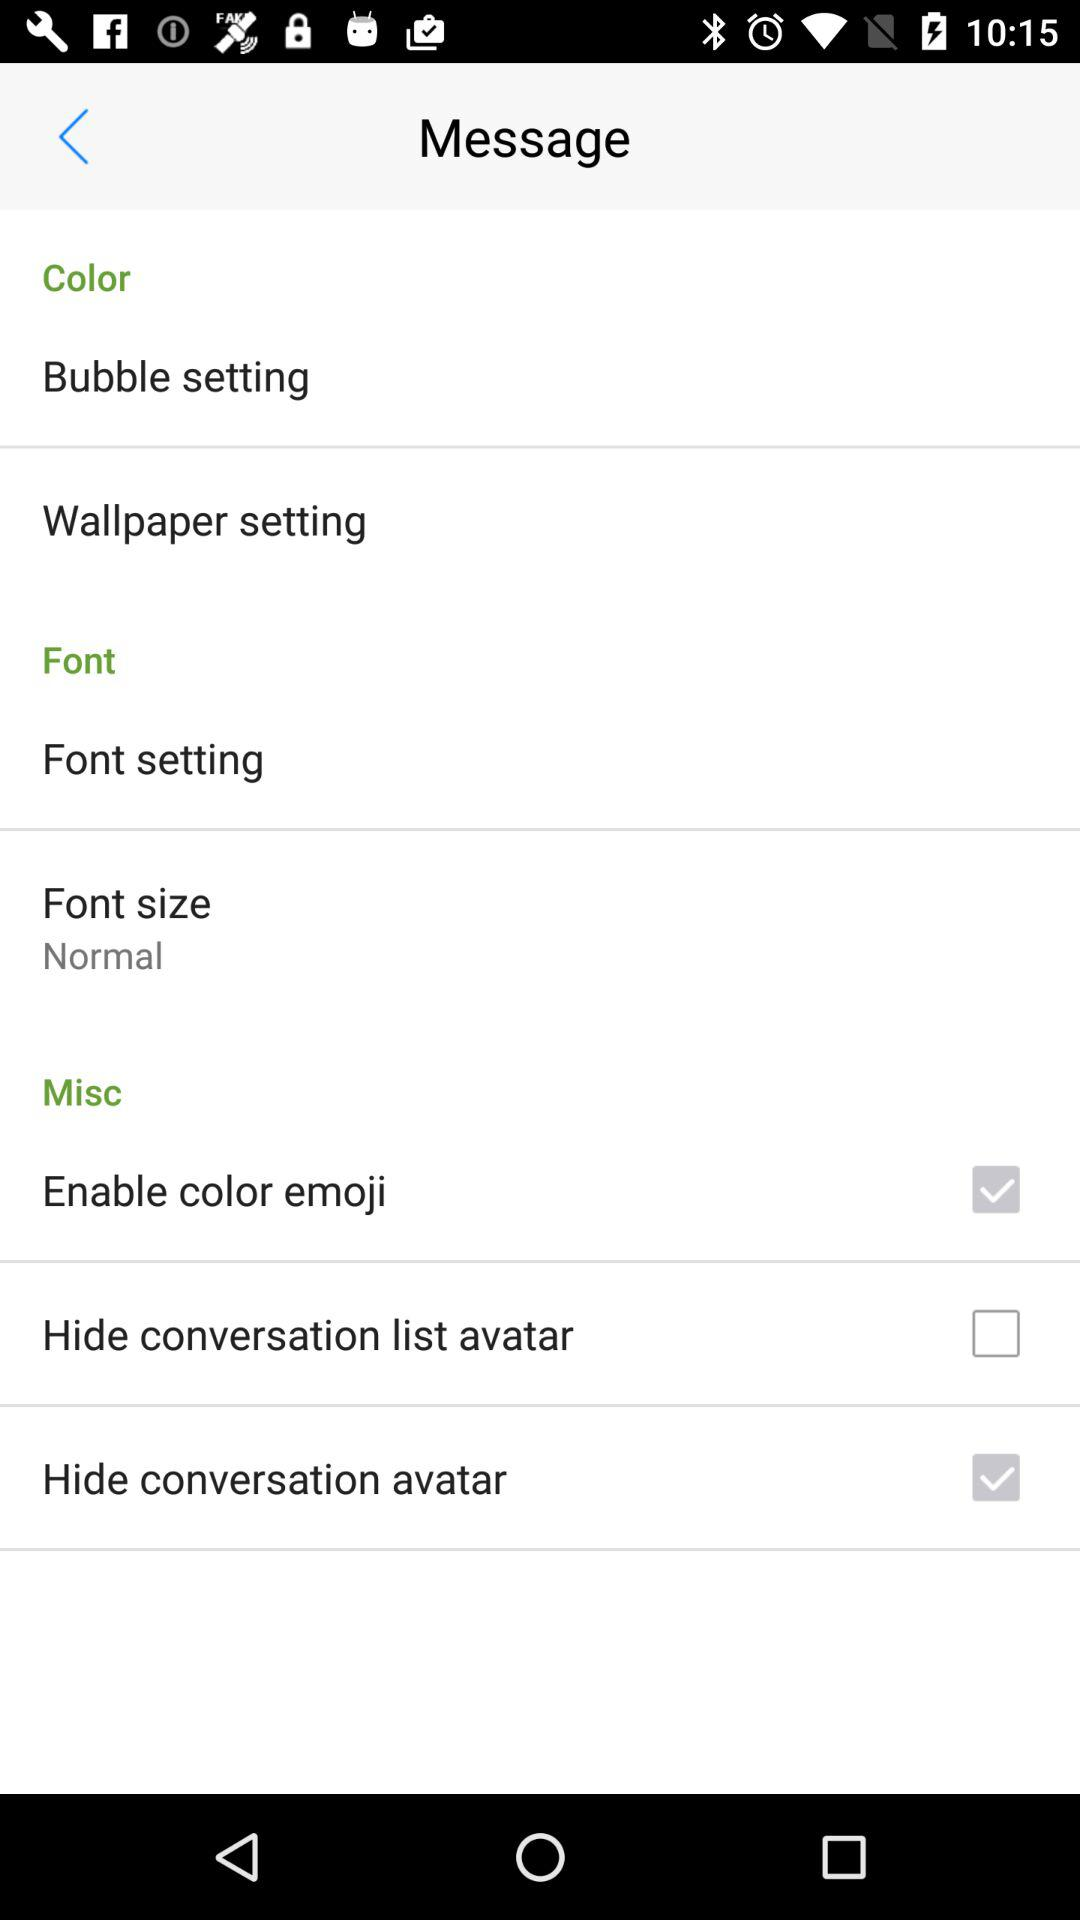What is the status of "Hide conversation avatar"? The status is "on". 